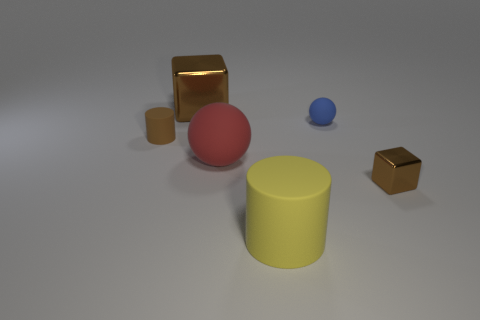Add 1 tiny red objects. How many objects exist? 7 Subtract all red balls. How many balls are left? 1 Add 2 brown metal things. How many brown metal things are left? 4 Add 5 tiny green rubber cylinders. How many tiny green rubber cylinders exist? 5 Subtract 1 blue spheres. How many objects are left? 5 Subtract all cylinders. How many objects are left? 4 Subtract 1 balls. How many balls are left? 1 Subtract all blue spheres. Subtract all green blocks. How many spheres are left? 1 Subtract all brown blocks. How many yellow cylinders are left? 1 Subtract all brown shiny cubes. Subtract all tiny things. How many objects are left? 1 